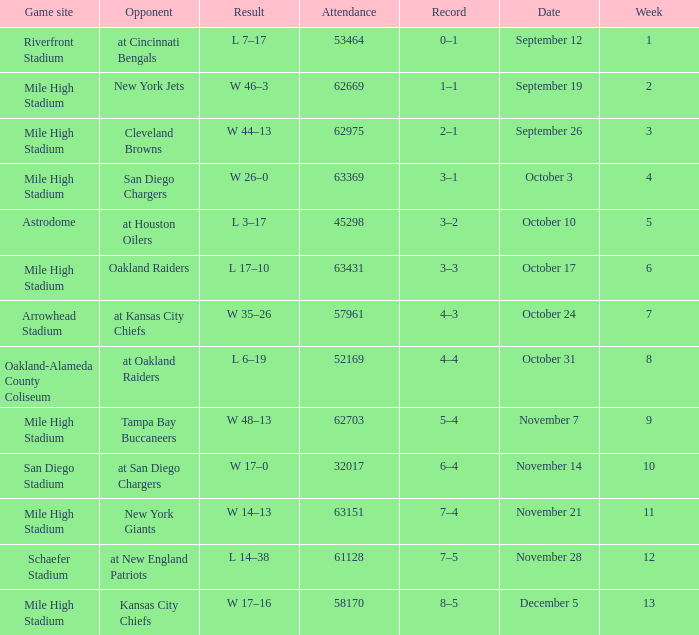What was the date of the week 4 game? October 3. 